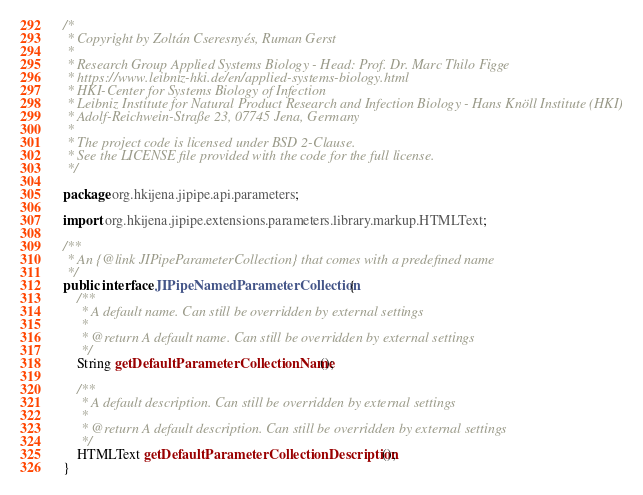Convert code to text. <code><loc_0><loc_0><loc_500><loc_500><_Java_>/*
 * Copyright by Zoltán Cseresnyés, Ruman Gerst
 *
 * Research Group Applied Systems Biology - Head: Prof. Dr. Marc Thilo Figge
 * https://www.leibniz-hki.de/en/applied-systems-biology.html
 * HKI-Center for Systems Biology of Infection
 * Leibniz Institute for Natural Product Research and Infection Biology - Hans Knöll Institute (HKI)
 * Adolf-Reichwein-Straße 23, 07745 Jena, Germany
 *
 * The project code is licensed under BSD 2-Clause.
 * See the LICENSE file provided with the code for the full license.
 */

package org.hkijena.jipipe.api.parameters;

import org.hkijena.jipipe.extensions.parameters.library.markup.HTMLText;

/**
 * An {@link JIPipeParameterCollection} that comes with a predefined name
 */
public interface JIPipeNamedParameterCollection {
    /**
     * A default name. Can still be overridden by external settings
     *
     * @return A default name. Can still be overridden by external settings
     */
    String getDefaultParameterCollectionName();

    /**
     * A default description. Can still be overridden by external settings
     *
     * @return A default description. Can still be overridden by external settings
     */
    HTMLText getDefaultParameterCollectionDescription();
}
</code> 